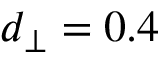<formula> <loc_0><loc_0><loc_500><loc_500>d _ { \perp } = 0 . 4</formula> 